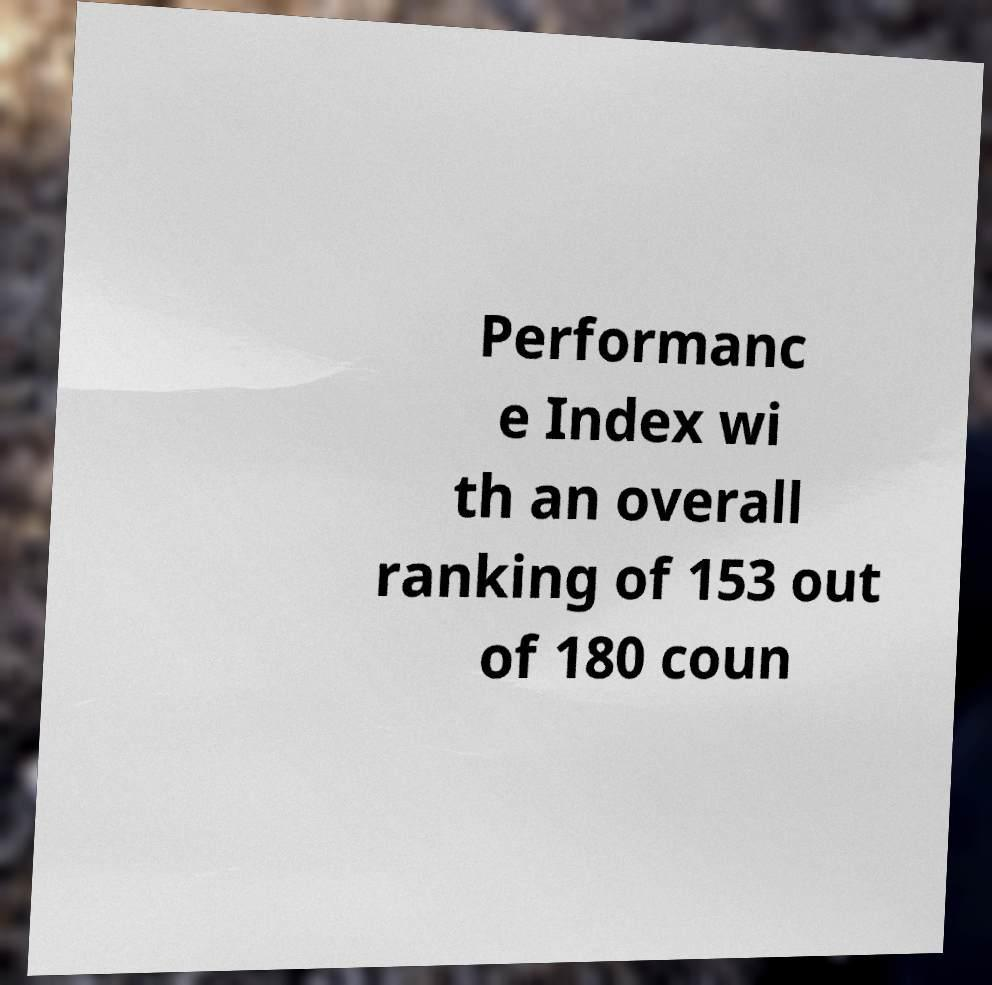Could you assist in decoding the text presented in this image and type it out clearly? Performanc e Index wi th an overall ranking of 153 out of 180 coun 